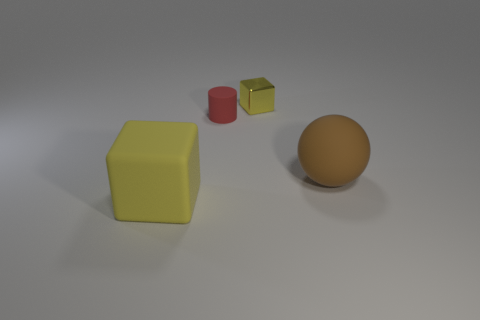Subtract all brown rubber spheres. Subtract all tiny blue shiny cylinders. How many objects are left? 3 Add 4 yellow metal blocks. How many yellow metal blocks are left? 5 Add 3 brown things. How many brown things exist? 4 Add 4 purple rubber objects. How many objects exist? 8 Subtract 0 green blocks. How many objects are left? 4 Subtract 1 cylinders. How many cylinders are left? 0 Subtract all cyan cubes. Subtract all brown balls. How many cubes are left? 2 